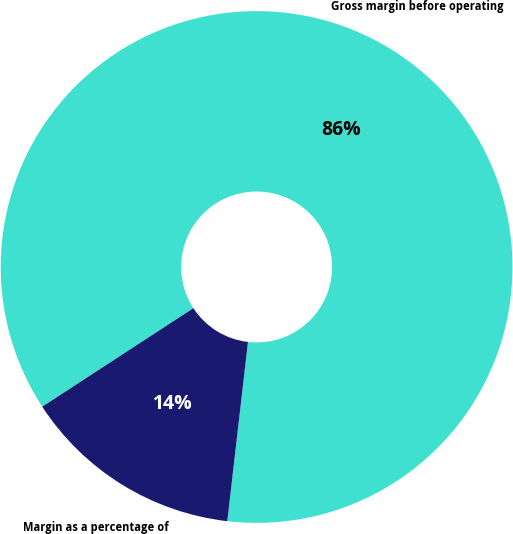Convert chart to OTSL. <chart><loc_0><loc_0><loc_500><loc_500><pie_chart><fcel>Gross margin before operating<fcel>Margin as a percentage of<nl><fcel>86.02%<fcel>13.98%<nl></chart> 